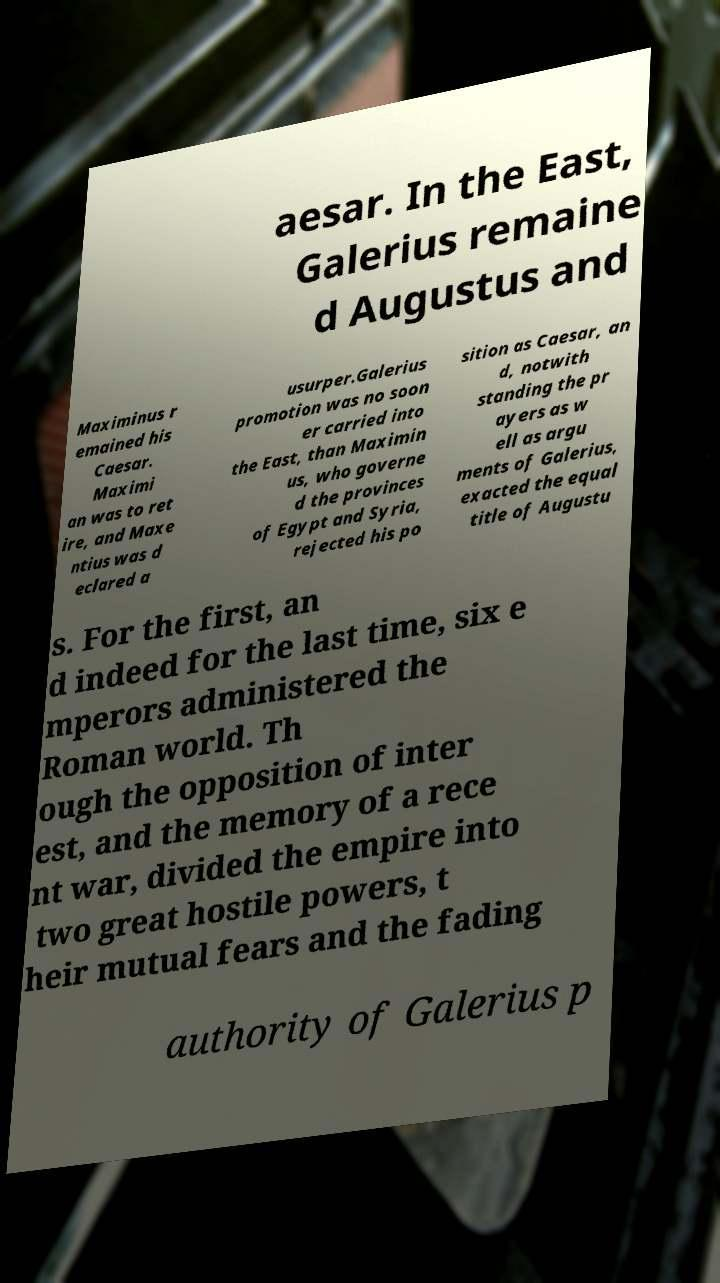I need the written content from this picture converted into text. Can you do that? aesar. In the East, Galerius remaine d Augustus and Maximinus r emained his Caesar. Maximi an was to ret ire, and Maxe ntius was d eclared a usurper.Galerius promotion was no soon er carried into the East, than Maximin us, who governe d the provinces of Egypt and Syria, rejected his po sition as Caesar, an d, notwith standing the pr ayers as w ell as argu ments of Galerius, exacted the equal title of Augustu s. For the first, an d indeed for the last time, six e mperors administered the Roman world. Th ough the opposition of inter est, and the memory of a rece nt war, divided the empire into two great hostile powers, t heir mutual fears and the fading authority of Galerius p 